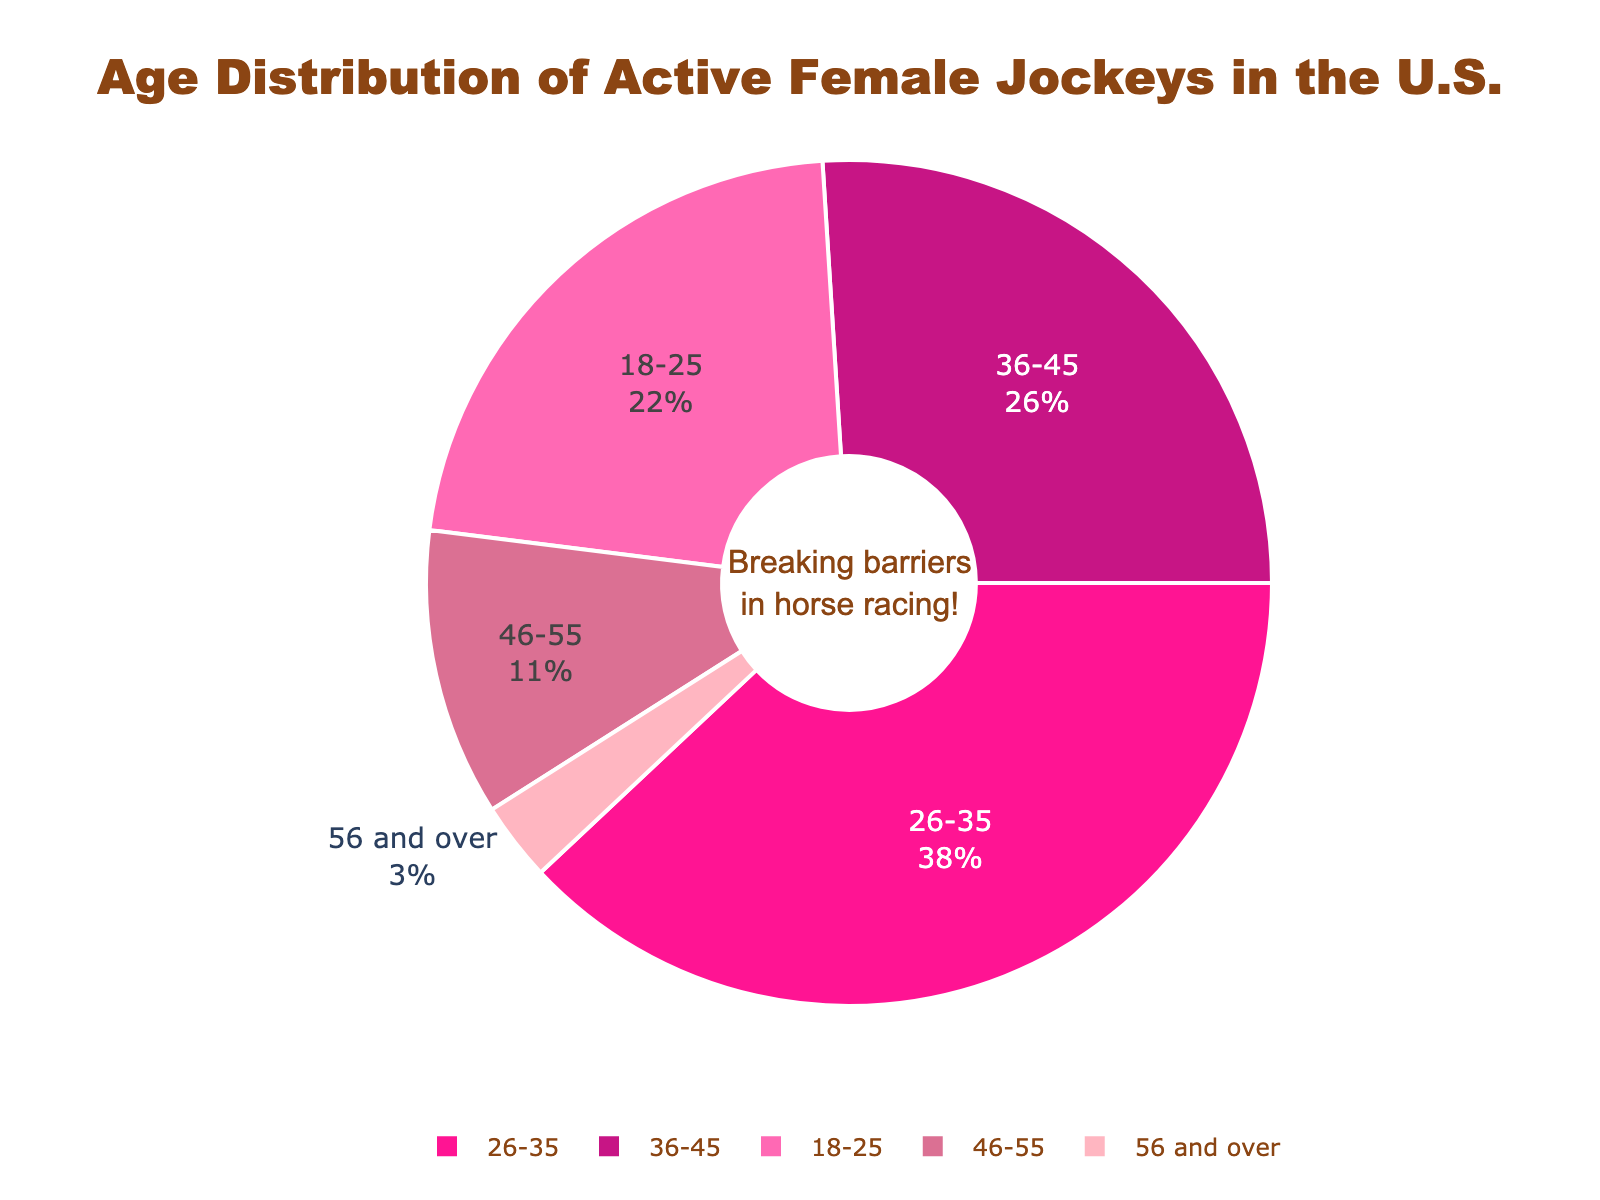What percentage of active female jockeys are between the ages of 18 and 35? To find the percentage of jockeys aged 18-35, add the percentages of the 18-25 and 26-35 age groups. That's 22% + 38% = 60%.
Answer: 60% Which age range has the lowest percentage of active female jockeys? The lowest percentage is found by comparing all age ranges. The 56 and over group has the smallest share at 3%.
Answer: 56 and over How many age ranges have a higher percentage of jockeys than the 46-55 range? Compare the 46-55 range (11%) to all other ranges. The 18-25 range (22%), 26-35 range (38%), and 36-45 range (26%) are higher. That's three ranges.
Answer: 3 Which age range has the highest representation among active female jockeys? By comparing the percentages, the 26-35 age range has the highest at 38%.
Answer: 26-35 What is the combined percentage of female jockeys aged 36 and over? Add the percentages of the 36-45, 46-55, and 56 and over age groups: 26% + 11% + 3% = 40%.
Answer: 40% How much greater is the percentage of jockeys aged 26-35 compared to those aged 46-55? Subtract the percentage of the 46-55 age group (11%) from the 26-35 group (38%). 38% - 11% = 27%.
Answer: 27% What percentage of active female jockeys are aged 45 or younger? Sum the percentages of the 18-25, 26-35, and 36-45 age groups: 22% + 38% + 26% = 86%.
Answer: 86% Which color is used to represent the age group with 11% of active female jockeys? The 46-55 age range is represented by the color associated with 11%. The visual chart shows this as the third color in the legend, which is represented by a light pink shade.
Answer: Light Pink What percentage difference is there between the age groups 18-25 and 36-45? Subtract the percentage of the 18-25 age group (22%) from the 36-45 group (26%). 26% - 22% = 4%.
Answer: 4% How does the representation of the 18-25 age group compare to the 56 and over age group? Compare the 18-25 age group (22%) to the 56 and over age group (3%). The 18-25 group has a significantly higher representation.
Answer: Higher 